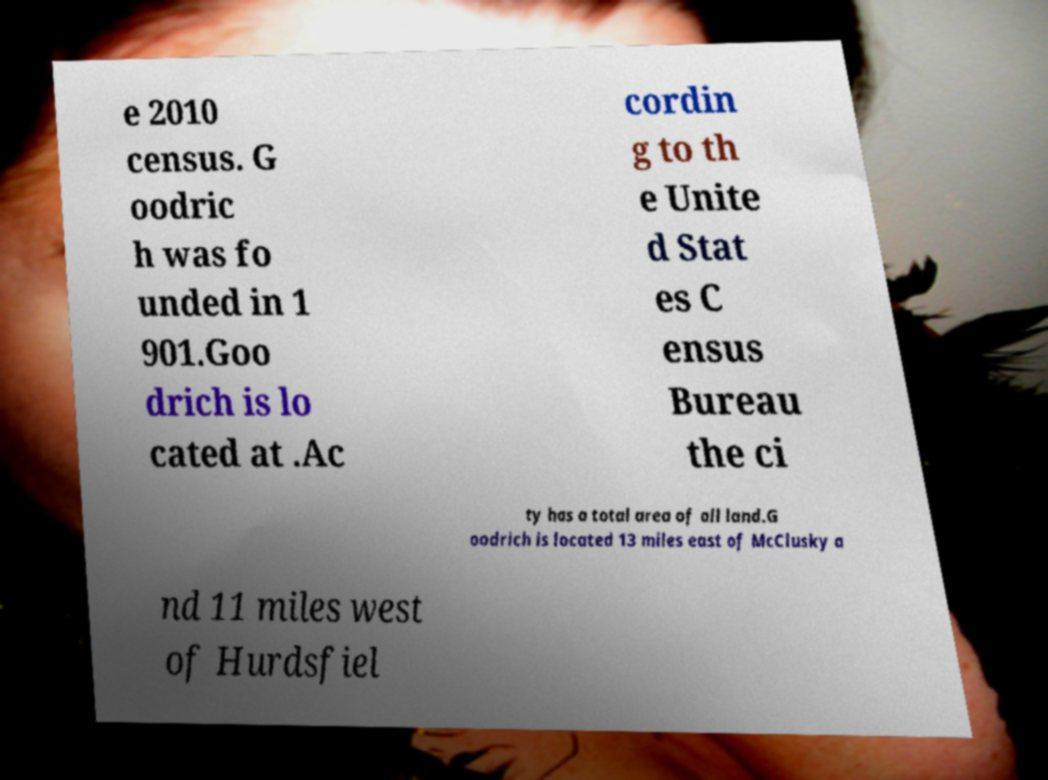Could you extract and type out the text from this image? e 2010 census. G oodric h was fo unded in 1 901.Goo drich is lo cated at .Ac cordin g to th e Unite d Stat es C ensus Bureau the ci ty has a total area of all land.G oodrich is located 13 miles east of McClusky a nd 11 miles west of Hurdsfiel 